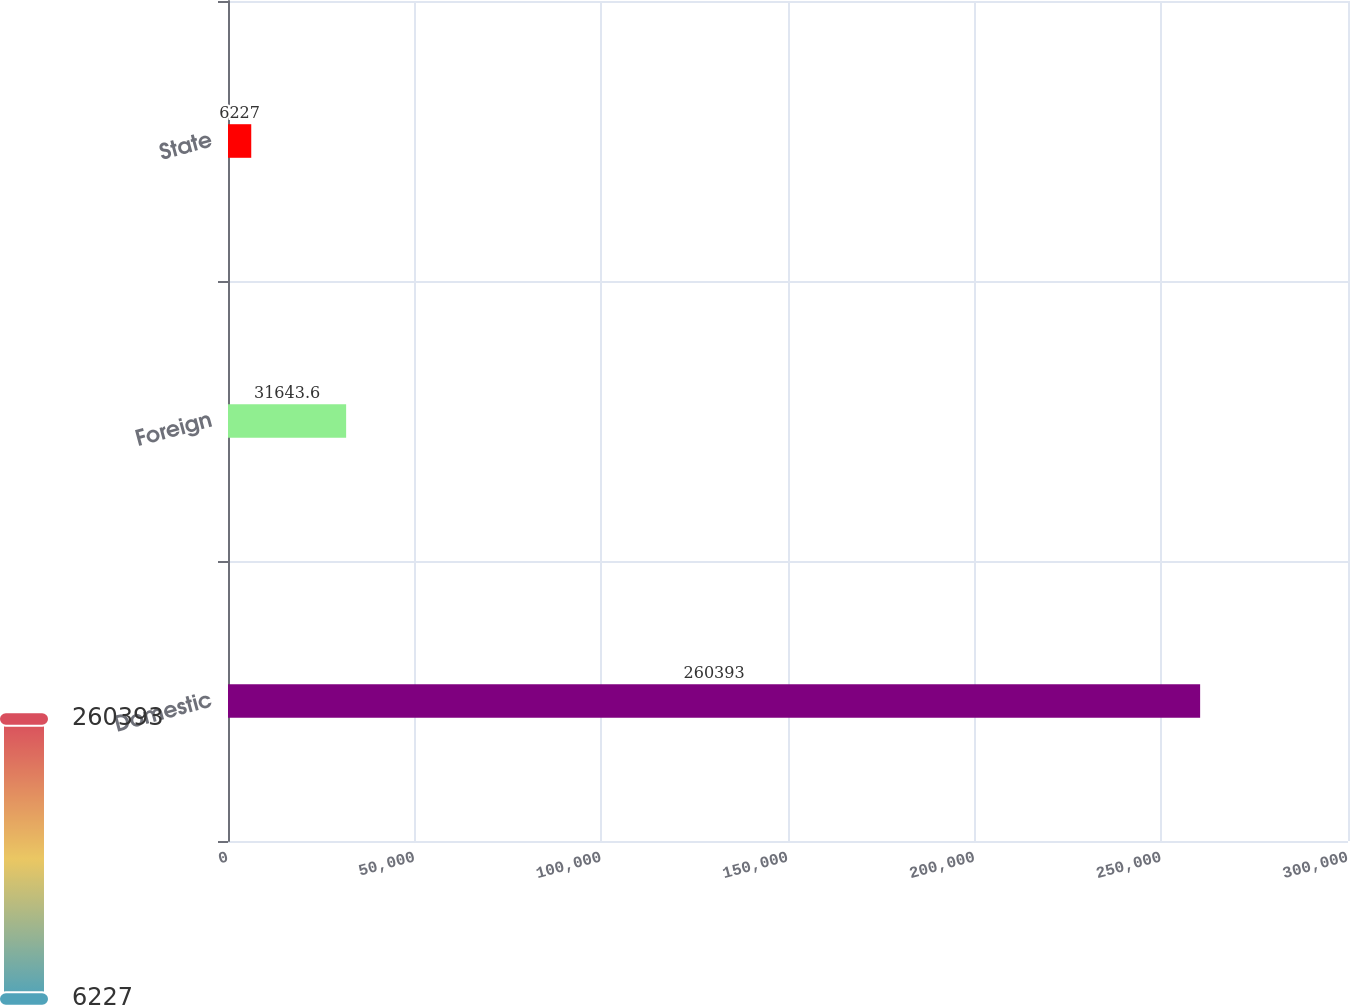<chart> <loc_0><loc_0><loc_500><loc_500><bar_chart><fcel>Domestic<fcel>Foreign<fcel>State<nl><fcel>260393<fcel>31643.6<fcel>6227<nl></chart> 